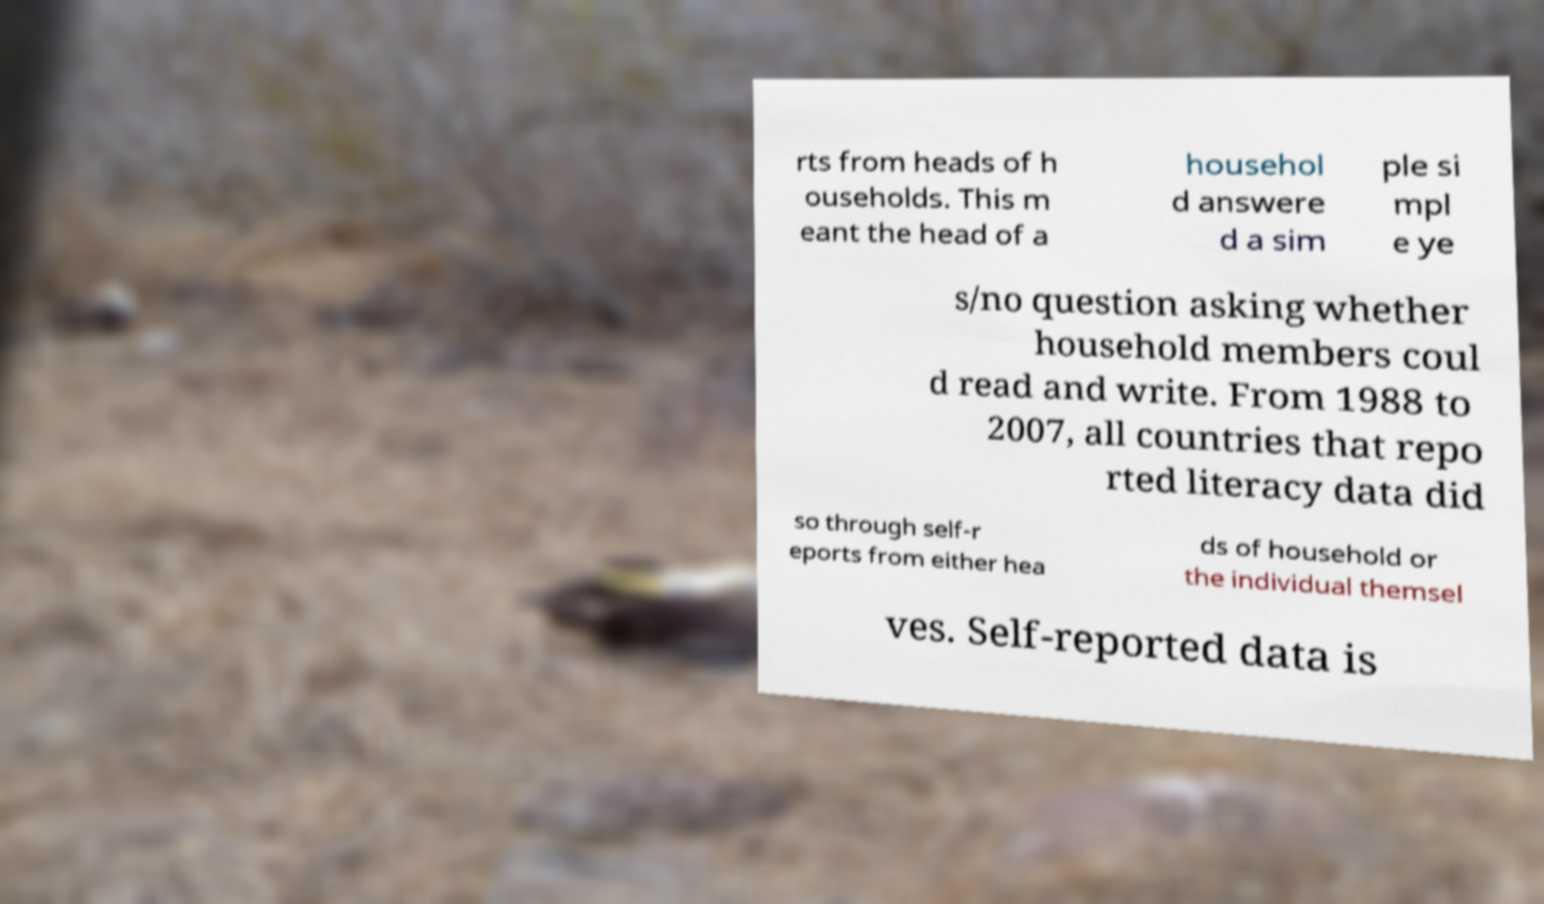Could you assist in decoding the text presented in this image and type it out clearly? rts from heads of h ouseholds. This m eant the head of a househol d answere d a sim ple si mpl e ye s/no question asking whether household members coul d read and write. From 1988 to 2007, all countries that repo rted literacy data did so through self-r eports from either hea ds of household or the individual themsel ves. Self-reported data is 